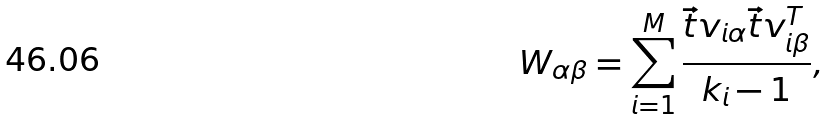<formula> <loc_0><loc_0><loc_500><loc_500>W _ { \alpha \beta } = \sum _ { i = 1 } ^ { M } \frac { \vec { t } { v } _ { i \alpha } \vec { t } { v } _ { i \beta } ^ { T } } { k _ { i } - 1 } ,</formula> 